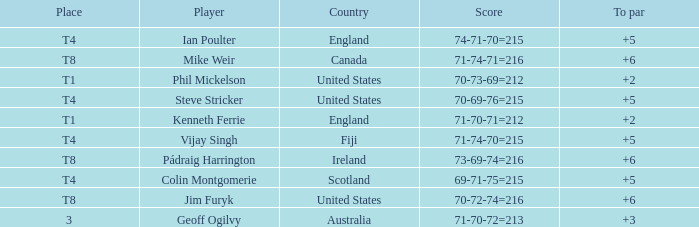What player was place of t1 in To Par and had a score of 70-73-69=212? 2.0. Can you parse all the data within this table? {'header': ['Place', 'Player', 'Country', 'Score', 'To par'], 'rows': [['T4', 'Ian Poulter', 'England', '74-71-70=215', '+5'], ['T8', 'Mike Weir', 'Canada', '71-74-71=216', '+6'], ['T1', 'Phil Mickelson', 'United States', '70-73-69=212', '+2'], ['T4', 'Steve Stricker', 'United States', '70-69-76=215', '+5'], ['T1', 'Kenneth Ferrie', 'England', '71-70-71=212', '+2'], ['T4', 'Vijay Singh', 'Fiji', '71-74-70=215', '+5'], ['T8', 'Pádraig Harrington', 'Ireland', '73-69-74=216', '+6'], ['T4', 'Colin Montgomerie', 'Scotland', '69-71-75=215', '+5'], ['T8', 'Jim Furyk', 'United States', '70-72-74=216', '+6'], ['3', 'Geoff Ogilvy', 'Australia', '71-70-72=213', '+3']]} 